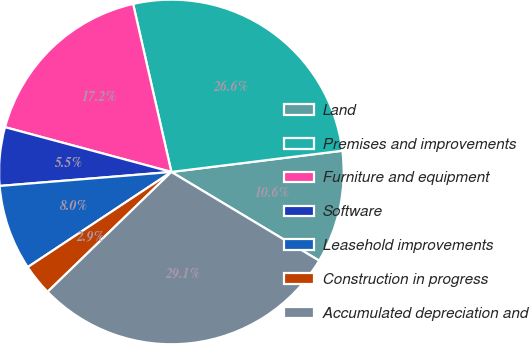Convert chart to OTSL. <chart><loc_0><loc_0><loc_500><loc_500><pie_chart><fcel>Land<fcel>Premises and improvements<fcel>Furniture and equipment<fcel>Software<fcel>Leasehold improvements<fcel>Construction in progress<fcel>Accumulated depreciation and<nl><fcel>10.57%<fcel>26.6%<fcel>17.25%<fcel>5.48%<fcel>8.02%<fcel>2.93%<fcel>29.15%<nl></chart> 